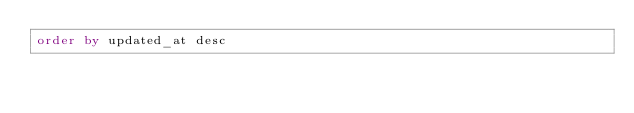Convert code to text. <code><loc_0><loc_0><loc_500><loc_500><_SQL_>order by updated_at desc
</code> 